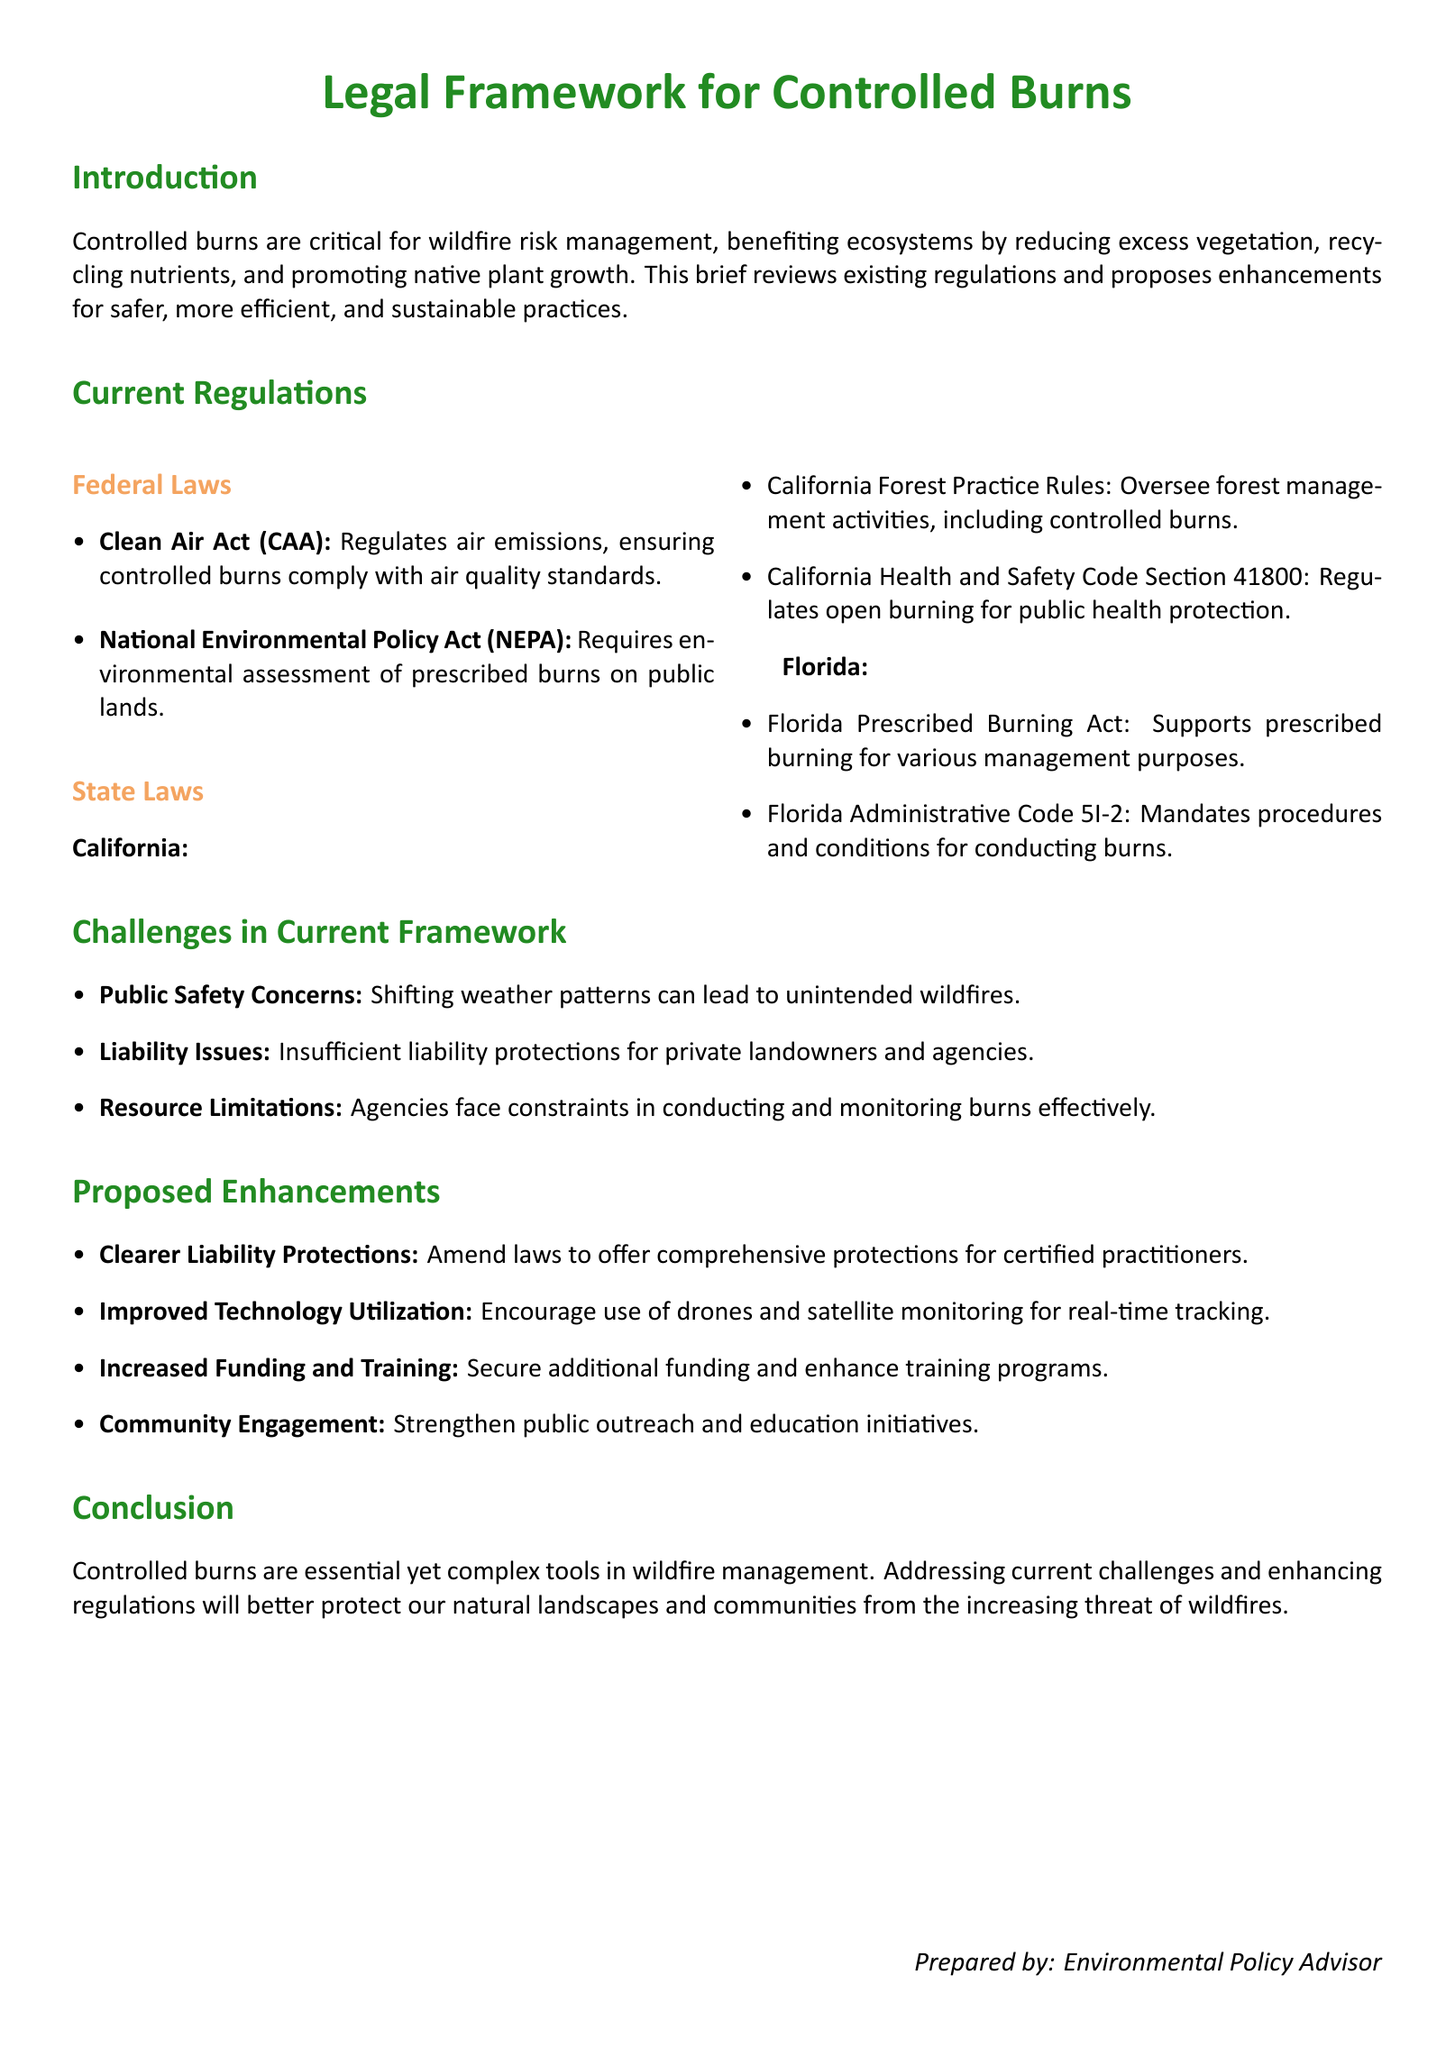What is the main purpose of controlled burns? The main purpose of controlled burns is to manage wildfire risk and benefit ecosystems by reducing excess vegetation, recycling nutrients, and promoting native plant growth.
Answer: To manage wildfire risk What federal act regulates air emissions related to controlled burns? The Clean Air Act (CAA) regulates air emissions, ensuring controlled burns comply with air quality standards.
Answer: Clean Air Act Which state has a specific law called the Florida Prescribed Burning Act? The Florida Prescribed Burning Act is specific to Florida, supporting prescribed burning for various management purposes.
Answer: Florida What is a challenge related to public safety mentioned in the document? Shifting weather patterns can lead to unintended wildfires, which is a public safety concern within the current framework.
Answer: Shifting weather patterns What enhancement is proposed to improve technology utilization? The document suggests encouraging the use of drones and satellite monitoring for real-time tracking to enhance controlled burn practices.
Answer: Drones and satellite monitoring What is the total number of federal laws mentioned? Two federal laws are mentioned: the Clean Air Act and the National Environmental Policy Act (NEPA).
Answer: Two What should be strengthened according to the proposed enhancements section? The proposed enhancements suggest strengthening public outreach and education initiatives regarding controlled burns.
Answer: Public outreach and education initiatives Which emotion may be related to liability issues mentioned in the document? The document states that there are insufficient liability protections for private landowners and agencies, indicating possible concern or anxiety.
Answer: Concern 